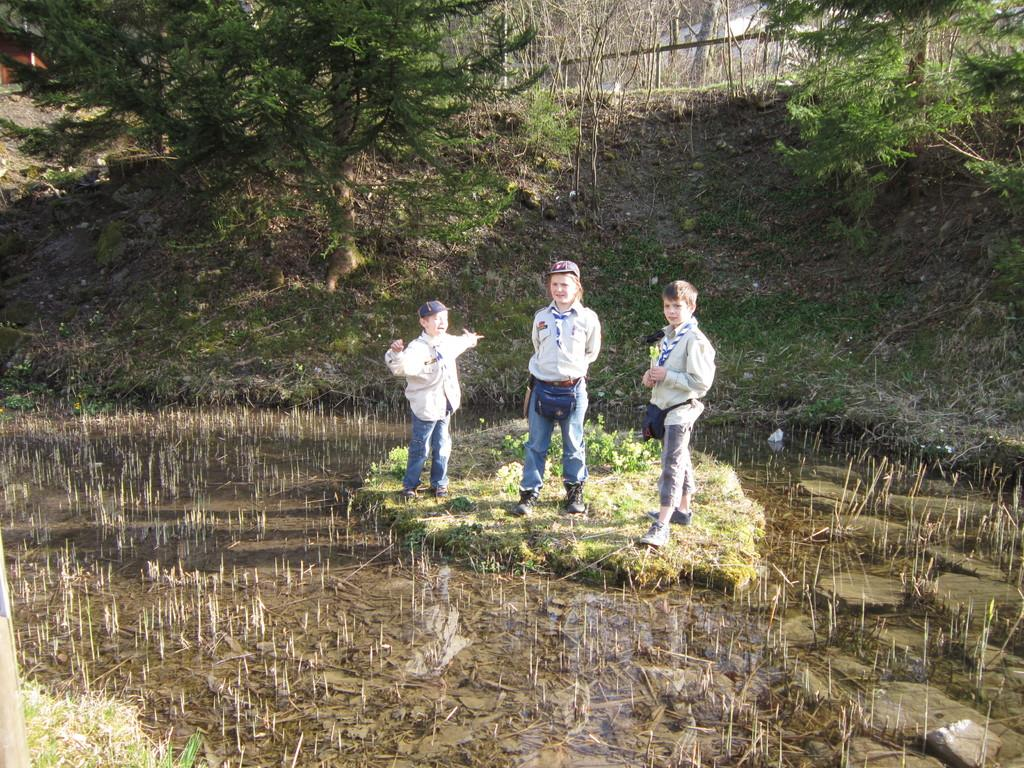Who is present in the image? There are children in the image. What are the children wearing? The children are wearing uniforms and shoes. Where are the children standing? The children are standing on the grass. What can be seen in the background of the image? There is water, stones, and trees visible in the background. What type of addition problem can be solved using the stones in the image? There are no addition problems or stones used for solving problems in the image; the stones are part of the background landscape. 